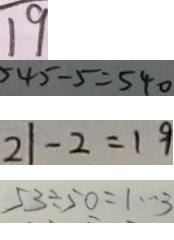Convert formula to latex. <formula><loc_0><loc_0><loc_500><loc_500>1 9 
 5 4 5 - 5 = 5 4 0 
 2 1 - 2 = 1 9 
 5 3 \div 5 0 = 1 \cdots 3</formula> 